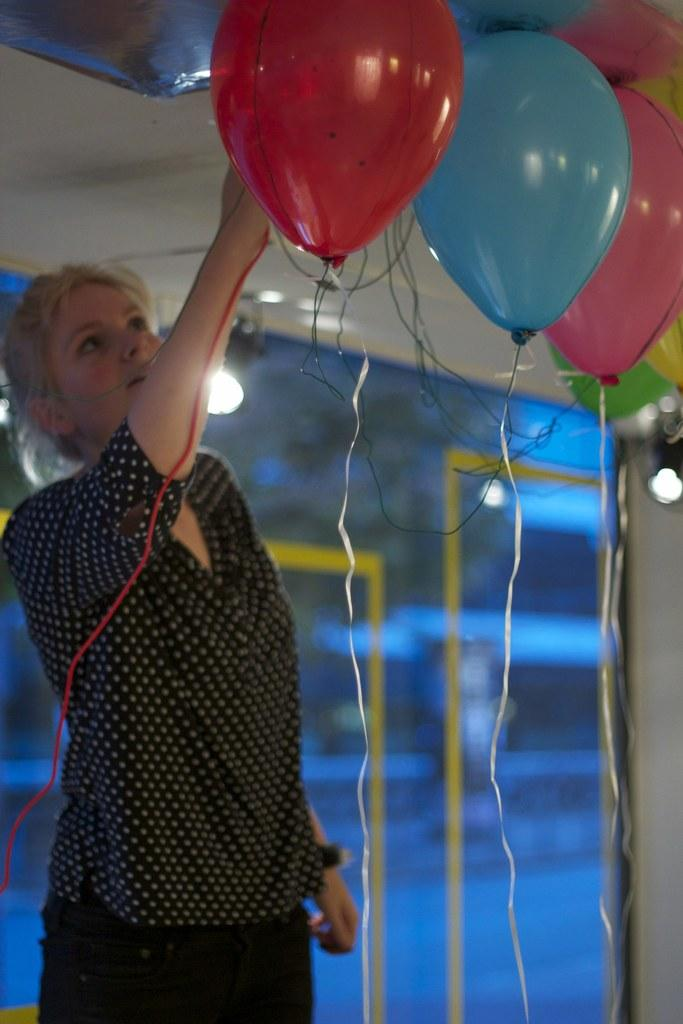Who is present in the image? There is a woman in the image. What objects can be seen in the image? There are balloons and lights in the image. What architectural feature is visible in the image? There is a window in the image. How would you describe the background of the image? The background of the image is blurred. How many pies are being measured on the mountain in the image? There are no pies or mountains present in the image. 